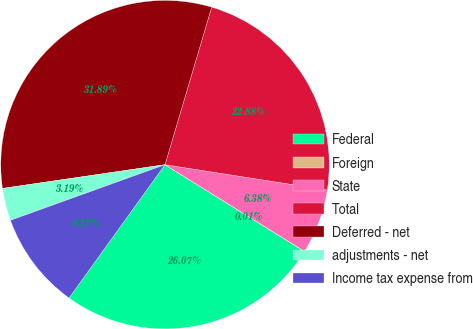Convert chart. <chart><loc_0><loc_0><loc_500><loc_500><pie_chart><fcel>Federal<fcel>Foreign<fcel>State<fcel>Total<fcel>Deferred - net<fcel>adjustments - net<fcel>Income tax expense from<nl><fcel>26.07%<fcel>0.01%<fcel>6.38%<fcel>22.88%<fcel>31.89%<fcel>3.19%<fcel>9.57%<nl></chart> 